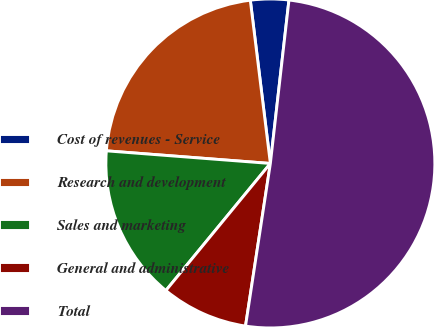Convert chart. <chart><loc_0><loc_0><loc_500><loc_500><pie_chart><fcel>Cost of revenues - Service<fcel>Research and development<fcel>Sales and marketing<fcel>General and administrative<fcel>Total<nl><fcel>3.75%<fcel>21.83%<fcel>15.27%<fcel>8.54%<fcel>50.61%<nl></chart> 